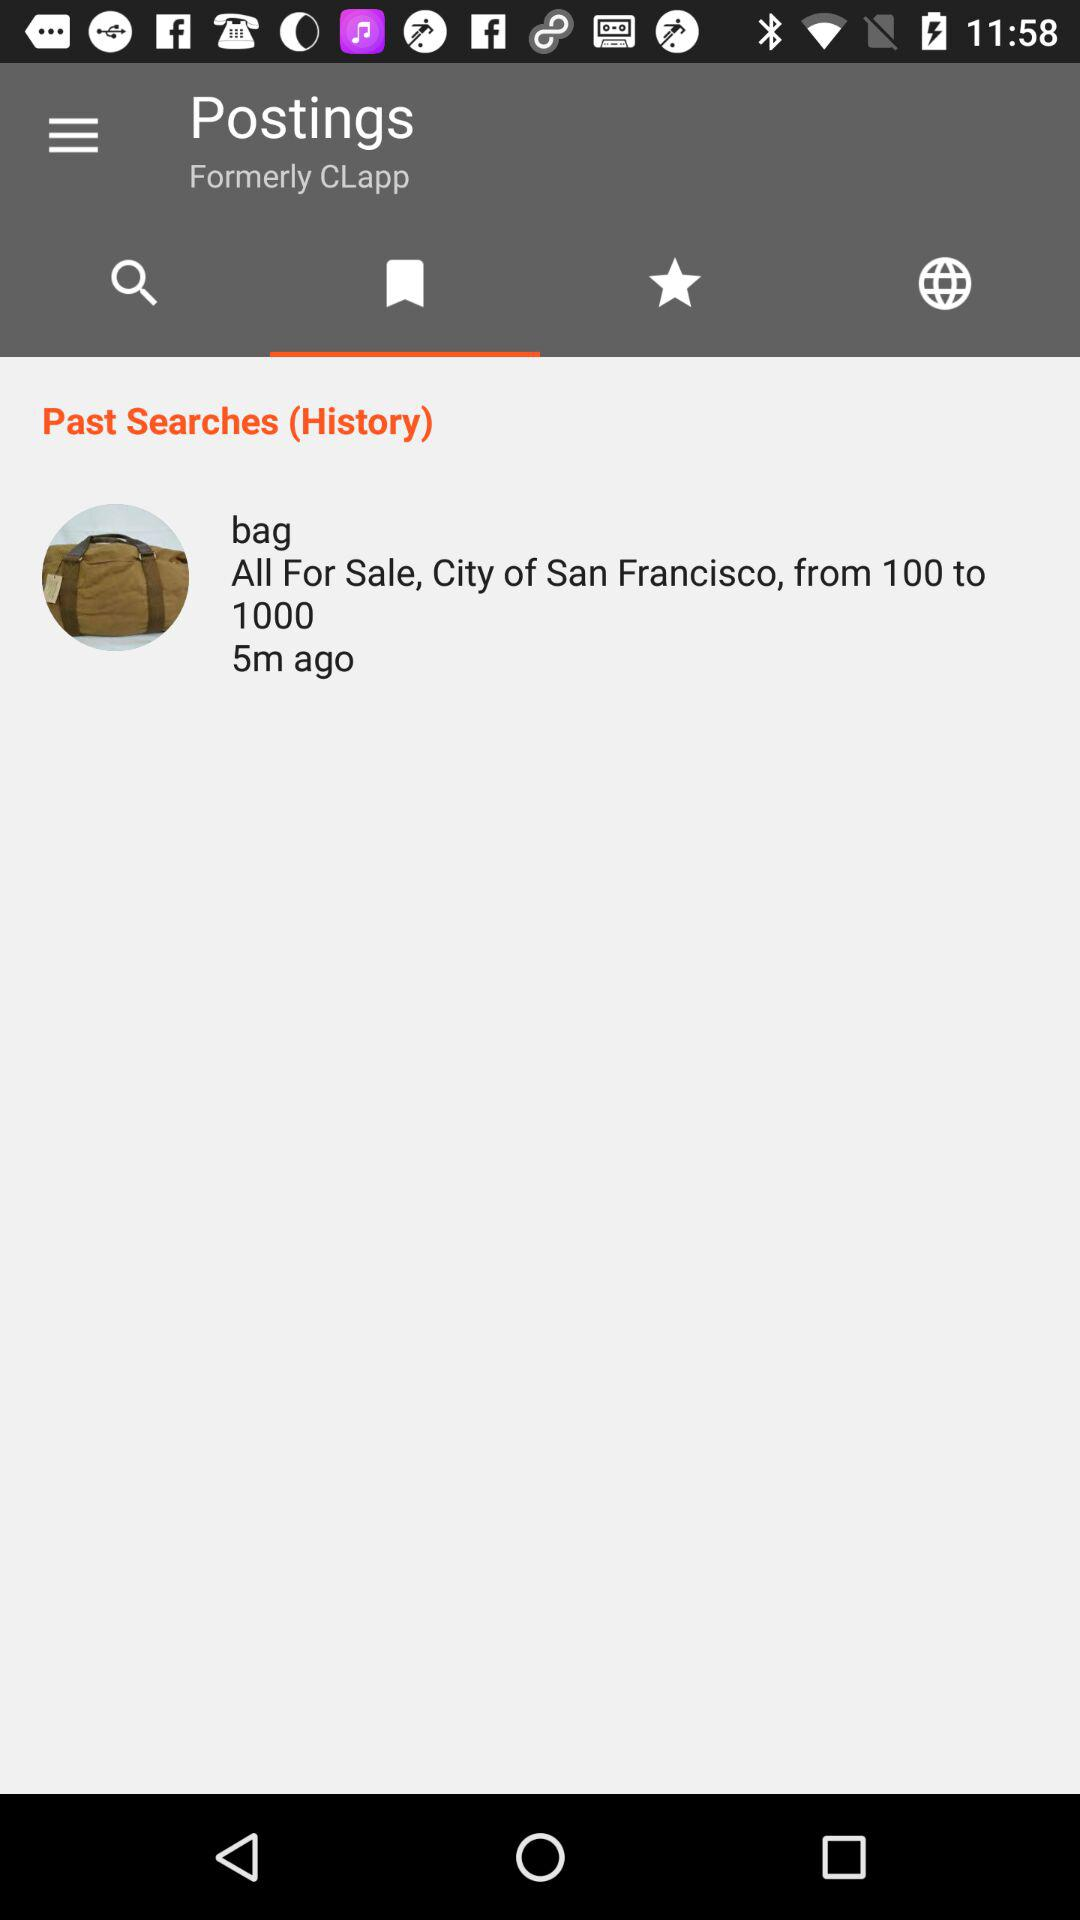What is the name of the city for the bag sale? The name of the city is San Francisco. 